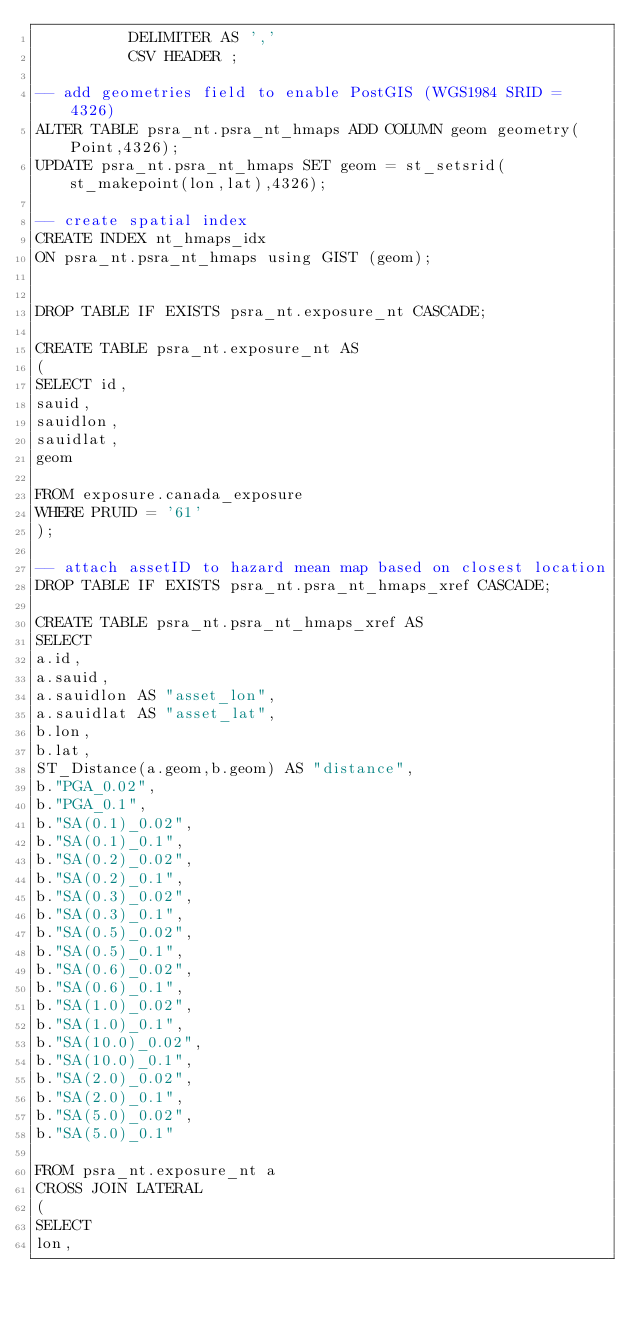Convert code to text. <code><loc_0><loc_0><loc_500><loc_500><_SQL_>          DELIMITER AS ','
          CSV HEADER ;

-- add geometries field to enable PostGIS (WGS1984 SRID = 4326)
ALTER TABLE psra_nt.psra_nt_hmaps ADD COLUMN geom geometry(Point,4326);
UPDATE psra_nt.psra_nt_hmaps SET geom = st_setsrid(st_makepoint(lon,lat),4326);

-- create spatial index
CREATE INDEX nt_hmaps_idx
ON psra_nt.psra_nt_hmaps using GIST (geom);


DROP TABLE IF EXISTS psra_nt.exposure_nt CASCADE;

CREATE TABLE psra_nt.exposure_nt AS
(
SELECT id,
sauid,
sauidlon,
sauidlat,
geom

FROM exposure.canada_exposure 
WHERE PRUID = '61'
);

-- attach assetID to hazard mean map based on closest location
DROP TABLE IF EXISTS psra_nt.psra_nt_hmaps_xref CASCADE;

CREATE TABLE psra_nt.psra_nt_hmaps_xref AS
SELECT
a.id,
a.sauid,
a.sauidlon AS "asset_lon",
a.sauidlat AS "asset_lat",
b.lon,
b.lat,
ST_Distance(a.geom,b.geom) AS "distance",
b."PGA_0.02",
b."PGA_0.1",
b."SA(0.1)_0.02",
b."SA(0.1)_0.1",
b."SA(0.2)_0.02",
b."SA(0.2)_0.1",
b."SA(0.3)_0.02",
b."SA(0.3)_0.1",
b."SA(0.5)_0.02",
b."SA(0.5)_0.1",
b."SA(0.6)_0.02",
b."SA(0.6)_0.1",
b."SA(1.0)_0.02",
b."SA(1.0)_0.1",
b."SA(10.0)_0.02",
b."SA(10.0)_0.1",
b."SA(2.0)_0.02",
b."SA(2.0)_0.1",
b."SA(5.0)_0.02",
b."SA(5.0)_0.1"

FROM psra_nt.exposure_nt a
CROSS JOIN LATERAL 
(
SELECT 
lon,</code> 